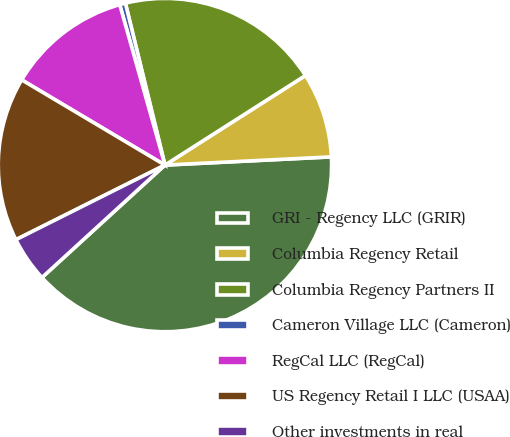<chart> <loc_0><loc_0><loc_500><loc_500><pie_chart><fcel>GRI - Regency LLC (GRIR)<fcel>Columbia Regency Retail<fcel>Columbia Regency Partners II<fcel>Cameron Village LLC (Cameron)<fcel>RegCal LLC (RegCal)<fcel>US Regency Retail I LLC (USAA)<fcel>Other investments in real<nl><fcel>39.0%<fcel>8.25%<fcel>19.78%<fcel>0.56%<fcel>12.09%<fcel>15.93%<fcel>4.4%<nl></chart> 